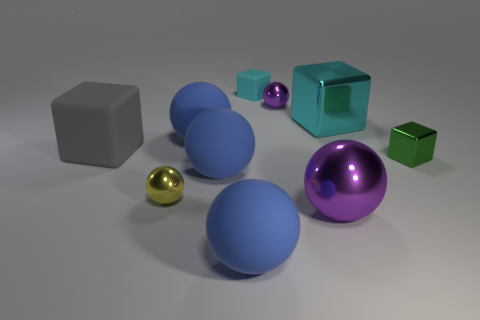Subtract all green cylinders. How many blue spheres are left? 3 Subtract 2 balls. How many balls are left? 4 Subtract all purple spheres. How many spheres are left? 4 Subtract all big purple shiny balls. How many balls are left? 5 Subtract all yellow cubes. Subtract all green cylinders. How many cubes are left? 4 Subtract all balls. How many objects are left? 4 Subtract all blue things. Subtract all yellow metallic things. How many objects are left? 6 Add 8 small cyan cubes. How many small cyan cubes are left? 9 Add 6 blue matte things. How many blue matte things exist? 9 Subtract 0 green cylinders. How many objects are left? 10 